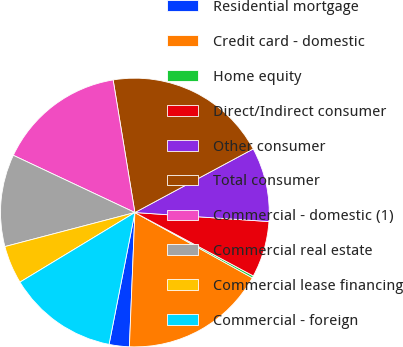Convert chart to OTSL. <chart><loc_0><loc_0><loc_500><loc_500><pie_chart><fcel>Residential mortgage<fcel>Credit card - domestic<fcel>Home equity<fcel>Direct/Indirect consumer<fcel>Other consumer<fcel>Total consumer<fcel>Commercial - domestic (1)<fcel>Commercial real estate<fcel>Commercial lease financing<fcel>Commercial - foreign<nl><fcel>2.43%<fcel>17.57%<fcel>0.26%<fcel>6.75%<fcel>8.92%<fcel>19.74%<fcel>15.41%<fcel>11.08%<fcel>4.59%<fcel>13.25%<nl></chart> 